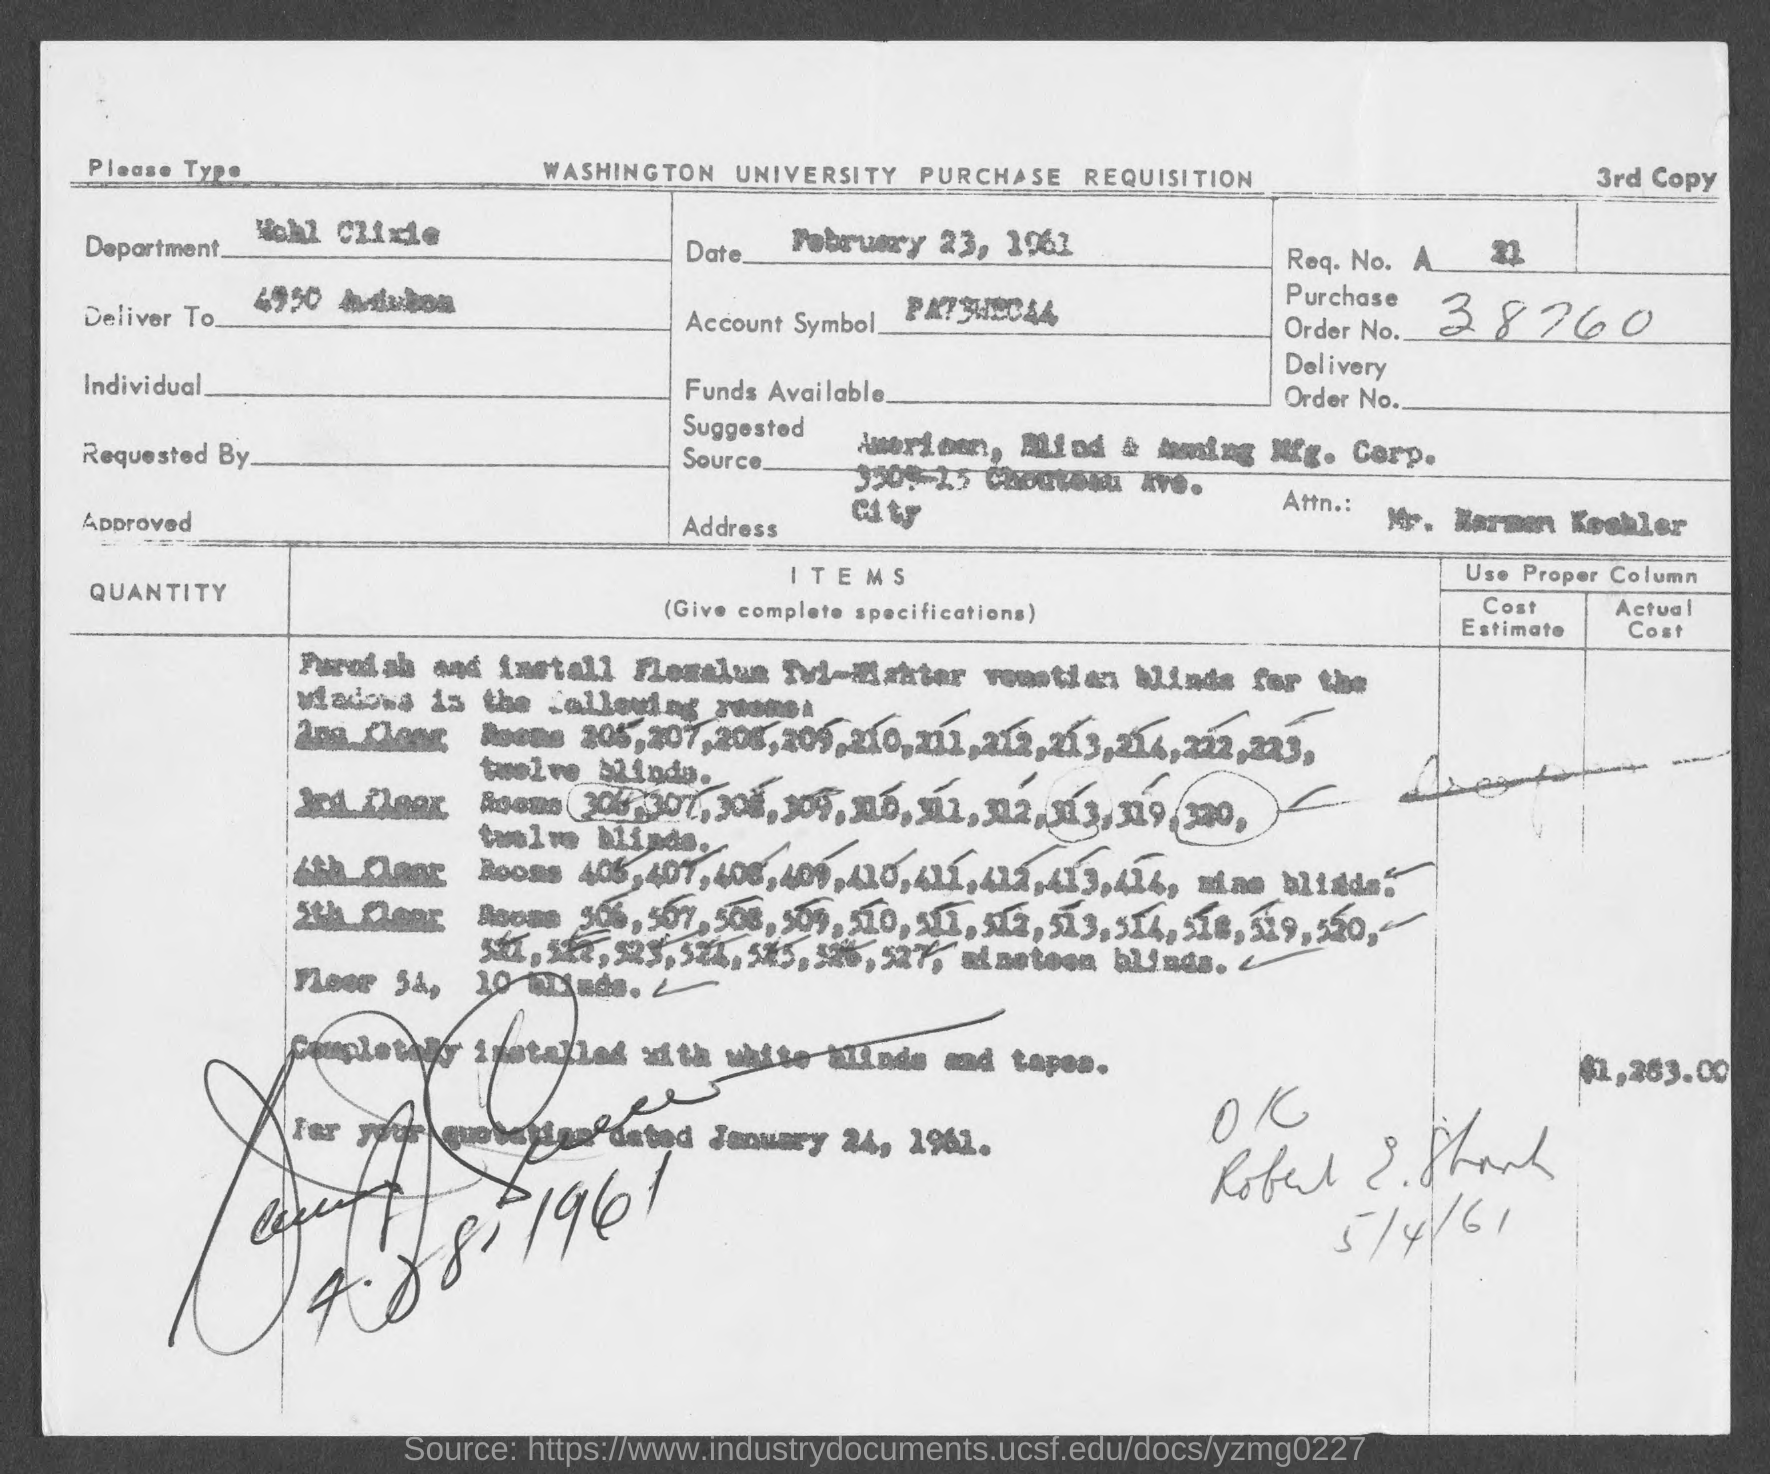Draw attention to some important aspects in this diagram. The date on the document is February 23, 1961. The Purchase Order Number is 38760. 